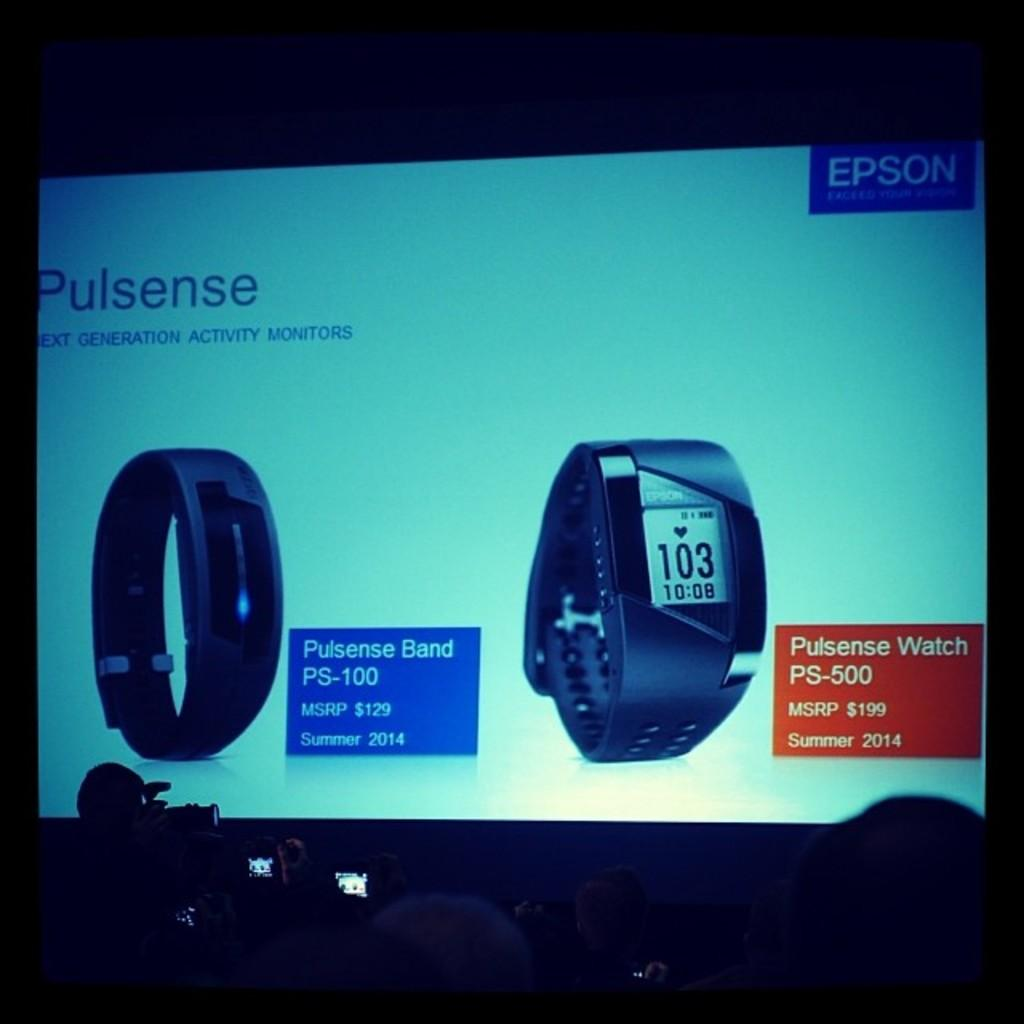<image>
Describe the image concisely. A large projector screen showing two Pulsense branded smart watches. 